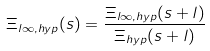<formula> <loc_0><loc_0><loc_500><loc_500>\Xi _ { l \infty , h y p } ( s ) = \frac { \Xi _ { l \infty , h y p } ( s + l ) } { \Xi _ { h y p } ( s + l ) }</formula> 